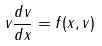Convert formula to latex. <formula><loc_0><loc_0><loc_500><loc_500>v \frac { d v } { d x } = f ( x , v )</formula> 